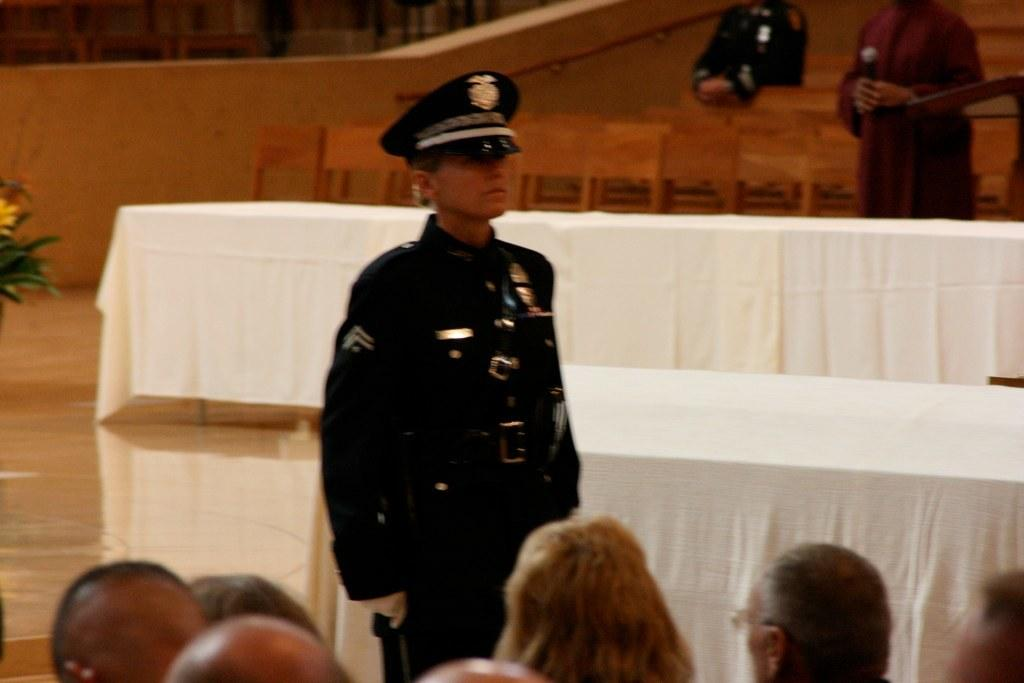What is the main subject of the image? There is a person standing in a uniform in the center of the image. Can you describe the people at the bottom of the image? There are people at the bottom of the image, but their specific actions or characteristics are not mentioned in the facts. What can be seen in the background of the image? There are chairs in the background of the image. What type of bell can be heard ringing in the image? There is no bell present or mentioned in the image, so it cannot be heard ringing. 